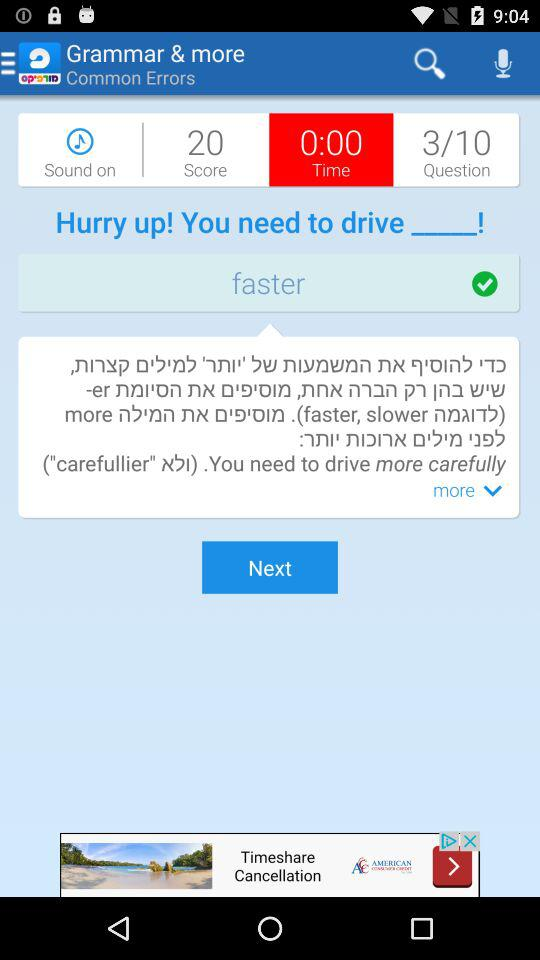What is the time? The time is 0:00. 